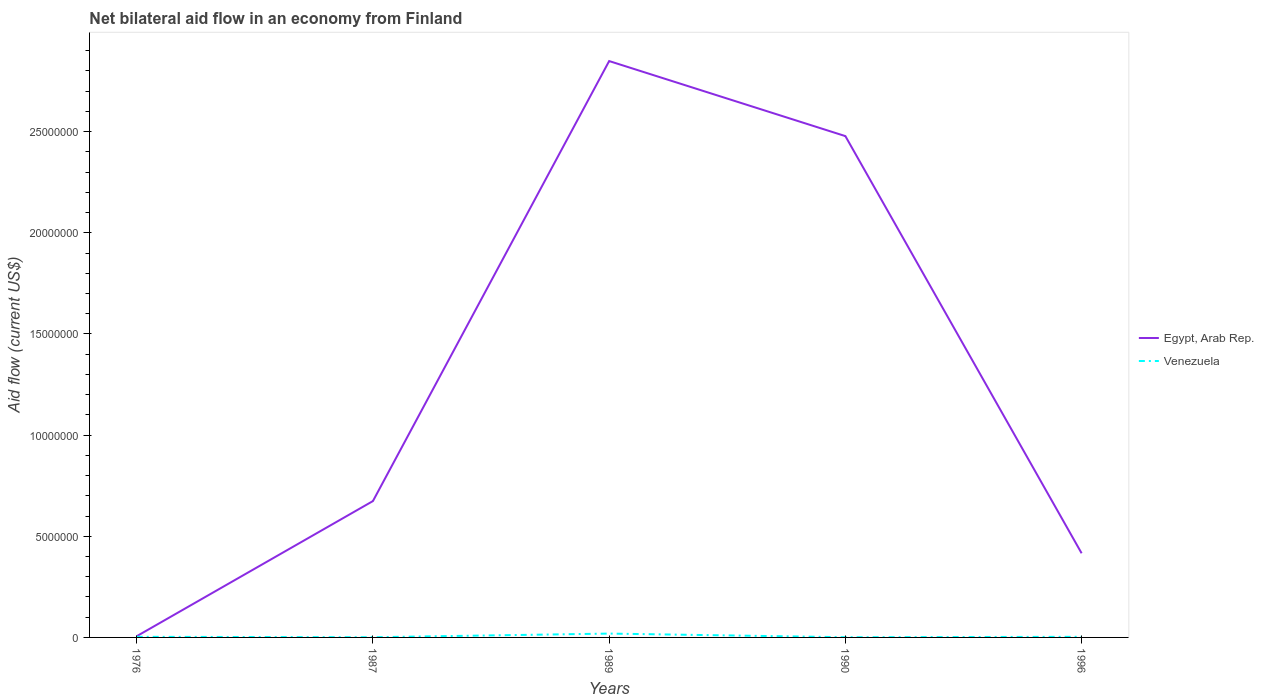How many different coloured lines are there?
Keep it short and to the point. 2. Across all years, what is the maximum net bilateral aid flow in Egypt, Arab Rep.?
Provide a short and direct response. 6.00e+04. In which year was the net bilateral aid flow in Venezuela maximum?
Offer a terse response. 1987. What is the total net bilateral aid flow in Egypt, Arab Rep. in the graph?
Provide a short and direct response. 2.06e+07. What is the difference between the highest and the second highest net bilateral aid flow in Egypt, Arab Rep.?
Offer a terse response. 2.84e+07. What is the difference between the highest and the lowest net bilateral aid flow in Venezuela?
Provide a succinct answer. 1. How many years are there in the graph?
Give a very brief answer. 5. What is the difference between two consecutive major ticks on the Y-axis?
Offer a very short reply. 5.00e+06. Are the values on the major ticks of Y-axis written in scientific E-notation?
Your response must be concise. No. Does the graph contain any zero values?
Offer a very short reply. No. Does the graph contain grids?
Ensure brevity in your answer.  No. How many legend labels are there?
Offer a very short reply. 2. How are the legend labels stacked?
Your answer should be very brief. Vertical. What is the title of the graph?
Your answer should be compact. Net bilateral aid flow in an economy from Finland. What is the label or title of the X-axis?
Ensure brevity in your answer.  Years. What is the Aid flow (current US$) of Egypt, Arab Rep. in 1987?
Give a very brief answer. 6.74e+06. What is the Aid flow (current US$) of Venezuela in 1987?
Offer a very short reply. 10000. What is the Aid flow (current US$) in Egypt, Arab Rep. in 1989?
Your answer should be very brief. 2.85e+07. What is the Aid flow (current US$) in Egypt, Arab Rep. in 1990?
Provide a short and direct response. 2.48e+07. What is the Aid flow (current US$) of Egypt, Arab Rep. in 1996?
Ensure brevity in your answer.  4.16e+06. What is the Aid flow (current US$) in Venezuela in 1996?
Make the answer very short. 3.00e+04. Across all years, what is the maximum Aid flow (current US$) of Egypt, Arab Rep.?
Give a very brief answer. 2.85e+07. Across all years, what is the maximum Aid flow (current US$) in Venezuela?
Make the answer very short. 1.90e+05. Across all years, what is the minimum Aid flow (current US$) in Venezuela?
Ensure brevity in your answer.  10000. What is the total Aid flow (current US$) in Egypt, Arab Rep. in the graph?
Your answer should be very brief. 6.42e+07. What is the difference between the Aid flow (current US$) in Egypt, Arab Rep. in 1976 and that in 1987?
Keep it short and to the point. -6.68e+06. What is the difference between the Aid flow (current US$) of Venezuela in 1976 and that in 1987?
Ensure brevity in your answer.  2.00e+04. What is the difference between the Aid flow (current US$) in Egypt, Arab Rep. in 1976 and that in 1989?
Ensure brevity in your answer.  -2.84e+07. What is the difference between the Aid flow (current US$) in Venezuela in 1976 and that in 1989?
Keep it short and to the point. -1.60e+05. What is the difference between the Aid flow (current US$) in Egypt, Arab Rep. in 1976 and that in 1990?
Your response must be concise. -2.47e+07. What is the difference between the Aid flow (current US$) of Egypt, Arab Rep. in 1976 and that in 1996?
Your answer should be very brief. -4.10e+06. What is the difference between the Aid flow (current US$) in Egypt, Arab Rep. in 1987 and that in 1989?
Your answer should be compact. -2.18e+07. What is the difference between the Aid flow (current US$) in Egypt, Arab Rep. in 1987 and that in 1990?
Provide a succinct answer. -1.80e+07. What is the difference between the Aid flow (current US$) of Egypt, Arab Rep. in 1987 and that in 1996?
Ensure brevity in your answer.  2.58e+06. What is the difference between the Aid flow (current US$) in Venezuela in 1987 and that in 1996?
Ensure brevity in your answer.  -2.00e+04. What is the difference between the Aid flow (current US$) of Egypt, Arab Rep. in 1989 and that in 1990?
Your answer should be compact. 3.71e+06. What is the difference between the Aid flow (current US$) of Egypt, Arab Rep. in 1989 and that in 1996?
Keep it short and to the point. 2.43e+07. What is the difference between the Aid flow (current US$) of Venezuela in 1989 and that in 1996?
Provide a succinct answer. 1.60e+05. What is the difference between the Aid flow (current US$) in Egypt, Arab Rep. in 1990 and that in 1996?
Your answer should be compact. 2.06e+07. What is the difference between the Aid flow (current US$) of Venezuela in 1990 and that in 1996?
Ensure brevity in your answer.  -2.00e+04. What is the difference between the Aid flow (current US$) of Egypt, Arab Rep. in 1976 and the Aid flow (current US$) of Venezuela in 1987?
Your answer should be compact. 5.00e+04. What is the difference between the Aid flow (current US$) of Egypt, Arab Rep. in 1976 and the Aid flow (current US$) of Venezuela in 1989?
Offer a very short reply. -1.30e+05. What is the difference between the Aid flow (current US$) in Egypt, Arab Rep. in 1976 and the Aid flow (current US$) in Venezuela in 1990?
Offer a very short reply. 5.00e+04. What is the difference between the Aid flow (current US$) of Egypt, Arab Rep. in 1976 and the Aid flow (current US$) of Venezuela in 1996?
Offer a very short reply. 3.00e+04. What is the difference between the Aid flow (current US$) in Egypt, Arab Rep. in 1987 and the Aid flow (current US$) in Venezuela in 1989?
Keep it short and to the point. 6.55e+06. What is the difference between the Aid flow (current US$) of Egypt, Arab Rep. in 1987 and the Aid flow (current US$) of Venezuela in 1990?
Keep it short and to the point. 6.73e+06. What is the difference between the Aid flow (current US$) in Egypt, Arab Rep. in 1987 and the Aid flow (current US$) in Venezuela in 1996?
Your answer should be compact. 6.71e+06. What is the difference between the Aid flow (current US$) of Egypt, Arab Rep. in 1989 and the Aid flow (current US$) of Venezuela in 1990?
Provide a short and direct response. 2.85e+07. What is the difference between the Aid flow (current US$) in Egypt, Arab Rep. in 1989 and the Aid flow (current US$) in Venezuela in 1996?
Provide a succinct answer. 2.85e+07. What is the difference between the Aid flow (current US$) of Egypt, Arab Rep. in 1990 and the Aid flow (current US$) of Venezuela in 1996?
Your answer should be very brief. 2.48e+07. What is the average Aid flow (current US$) in Egypt, Arab Rep. per year?
Your answer should be very brief. 1.28e+07. What is the average Aid flow (current US$) in Venezuela per year?
Your response must be concise. 5.40e+04. In the year 1987, what is the difference between the Aid flow (current US$) in Egypt, Arab Rep. and Aid flow (current US$) in Venezuela?
Your answer should be very brief. 6.73e+06. In the year 1989, what is the difference between the Aid flow (current US$) of Egypt, Arab Rep. and Aid flow (current US$) of Venezuela?
Your response must be concise. 2.83e+07. In the year 1990, what is the difference between the Aid flow (current US$) in Egypt, Arab Rep. and Aid flow (current US$) in Venezuela?
Offer a terse response. 2.48e+07. In the year 1996, what is the difference between the Aid flow (current US$) of Egypt, Arab Rep. and Aid flow (current US$) of Venezuela?
Your answer should be very brief. 4.13e+06. What is the ratio of the Aid flow (current US$) of Egypt, Arab Rep. in 1976 to that in 1987?
Offer a terse response. 0.01. What is the ratio of the Aid flow (current US$) in Egypt, Arab Rep. in 1976 to that in 1989?
Keep it short and to the point. 0. What is the ratio of the Aid flow (current US$) in Venezuela in 1976 to that in 1989?
Give a very brief answer. 0.16. What is the ratio of the Aid flow (current US$) of Egypt, Arab Rep. in 1976 to that in 1990?
Make the answer very short. 0. What is the ratio of the Aid flow (current US$) in Egypt, Arab Rep. in 1976 to that in 1996?
Keep it short and to the point. 0.01. What is the ratio of the Aid flow (current US$) of Egypt, Arab Rep. in 1987 to that in 1989?
Provide a succinct answer. 0.24. What is the ratio of the Aid flow (current US$) in Venezuela in 1987 to that in 1989?
Offer a terse response. 0.05. What is the ratio of the Aid flow (current US$) of Egypt, Arab Rep. in 1987 to that in 1990?
Make the answer very short. 0.27. What is the ratio of the Aid flow (current US$) in Venezuela in 1987 to that in 1990?
Ensure brevity in your answer.  1. What is the ratio of the Aid flow (current US$) of Egypt, Arab Rep. in 1987 to that in 1996?
Make the answer very short. 1.62. What is the ratio of the Aid flow (current US$) in Venezuela in 1987 to that in 1996?
Provide a succinct answer. 0.33. What is the ratio of the Aid flow (current US$) of Egypt, Arab Rep. in 1989 to that in 1990?
Give a very brief answer. 1.15. What is the ratio of the Aid flow (current US$) of Venezuela in 1989 to that in 1990?
Ensure brevity in your answer.  19. What is the ratio of the Aid flow (current US$) in Egypt, Arab Rep. in 1989 to that in 1996?
Give a very brief answer. 6.85. What is the ratio of the Aid flow (current US$) in Venezuela in 1989 to that in 1996?
Ensure brevity in your answer.  6.33. What is the ratio of the Aid flow (current US$) of Egypt, Arab Rep. in 1990 to that in 1996?
Provide a succinct answer. 5.96. What is the difference between the highest and the second highest Aid flow (current US$) in Egypt, Arab Rep.?
Ensure brevity in your answer.  3.71e+06. What is the difference between the highest and the second highest Aid flow (current US$) of Venezuela?
Keep it short and to the point. 1.60e+05. What is the difference between the highest and the lowest Aid flow (current US$) of Egypt, Arab Rep.?
Give a very brief answer. 2.84e+07. What is the difference between the highest and the lowest Aid flow (current US$) in Venezuela?
Your answer should be compact. 1.80e+05. 